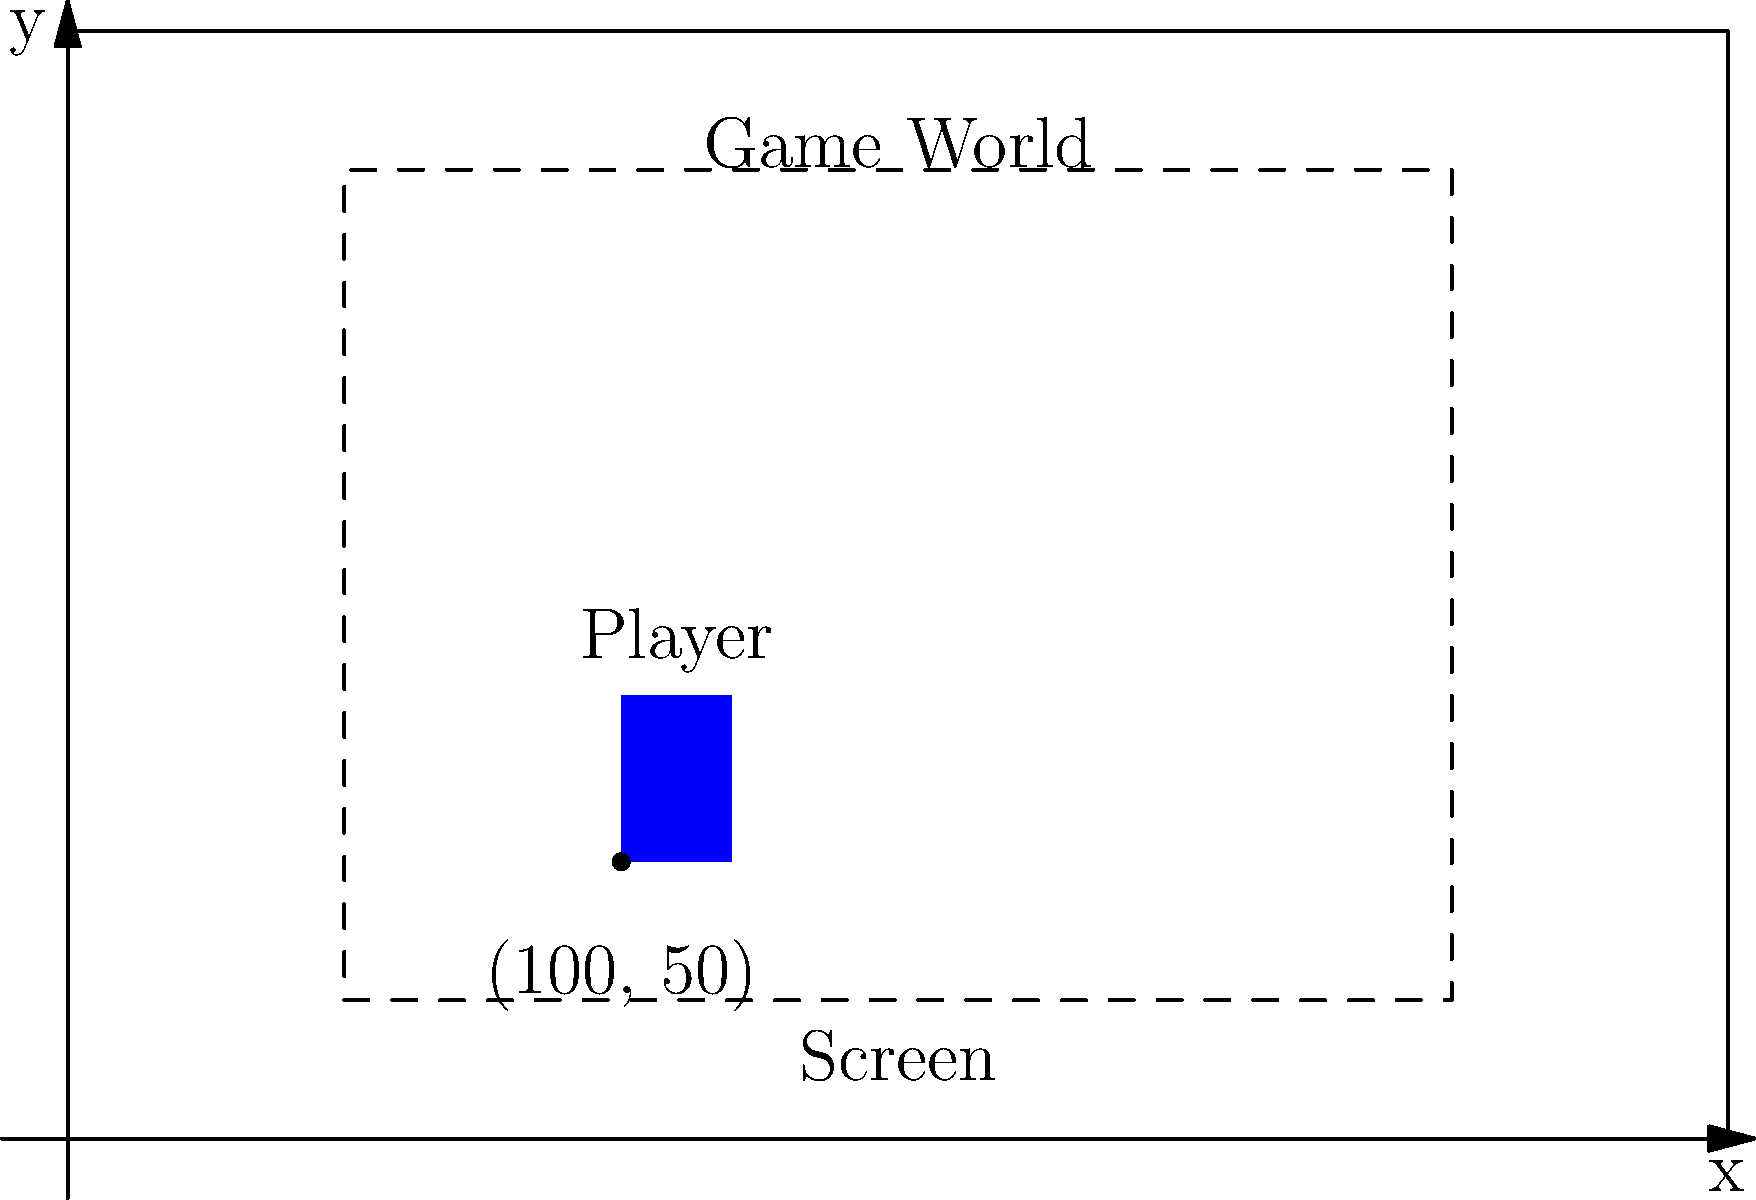In a side-scrolling platformer game, the player's position in the game world is (100, 50). The game screen is centered on the player and has a width of 200 units and a height of 150 units. If the game world origin (0, 0) is at the bottom-left corner, what would be the player's coordinates on the screen, assuming the screen's origin is at its top-left corner? Let's approach this step-by-step:

1) First, we need to understand the given information:
   - Player's position in the game world: (100, 50)
   - Screen dimensions: 200 units wide, 150 units high
   - Screen is centered on the player
   - Game world origin (0, 0) is at the bottom-left
   - Screen origin is at the top-left

2) To center the screen on the player, we need to calculate the screen's position in the game world:
   - Screen left edge: $x = 100 - 200/2 = 0$
   - Screen right edge: $x = 100 + 200/2 = 200$
   - Screen bottom edge: $y = 50 - 150/2 = -25$
   - Screen top edge: $y = 50 + 150/2 = 125$

3) Now, we can calculate the player's position relative to the screen:
   - X-coordinate: $100 - 0 = 100$
   - Y-coordinate: $125 - 50 = 75$

4) However, remember that the screen's origin is at the top-left, not the bottom-left. So we need to flip the Y-coordinate:
   - New Y-coordinate: $150 - 75 = 75$

Therefore, the player's coordinates on the screen are (100, 75).
Answer: (100, 75) 